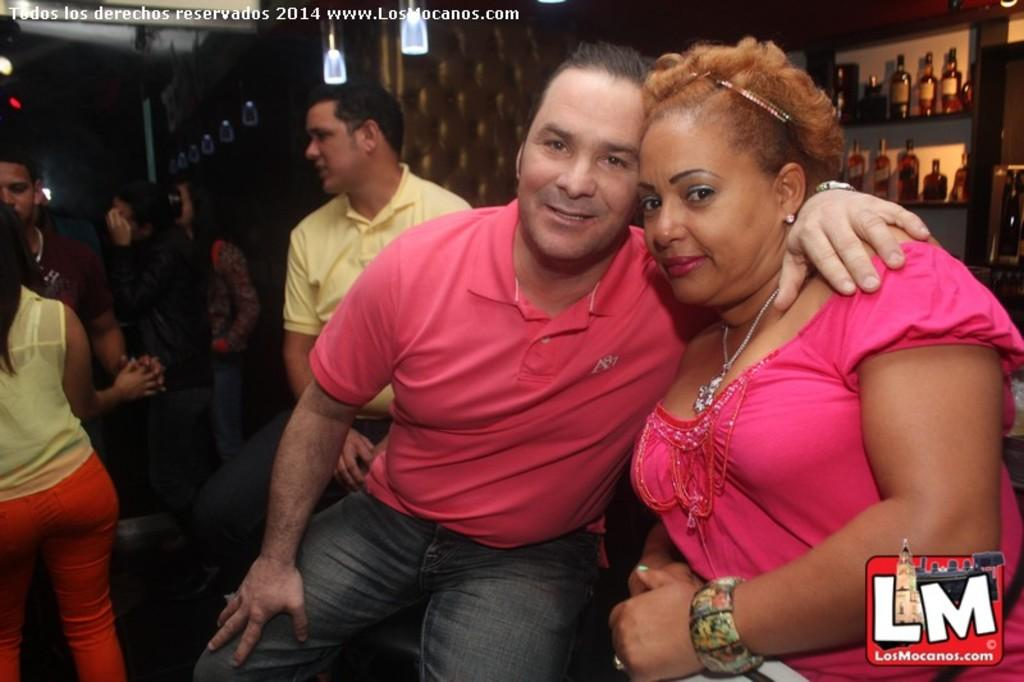What can be seen in the middle of the image? There are persons in the middle of the image. What is located at the top of the image? There are bottles and lights at the top of the image. Can you describe the people in the image? There are men and women in the image. What type of truck is visible in the image? There is no truck present in the image. What color are the trousers worn by the men in the image? The provided facts do not mention the color of the trousers worn by the men in the image. 